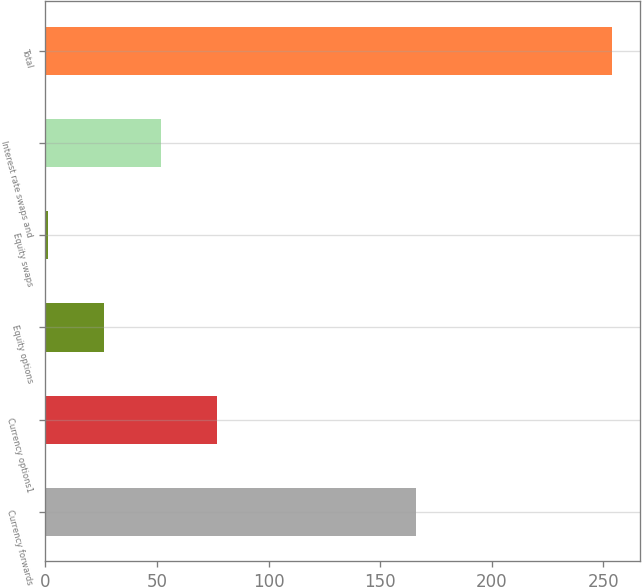Convert chart. <chart><loc_0><loc_0><loc_500><loc_500><bar_chart><fcel>Currency forwards<fcel>Currency options1<fcel>Equity options<fcel>Equity swaps<fcel>Interest rate swaps and<fcel>Total<nl><fcel>166<fcel>76.9<fcel>26.3<fcel>1<fcel>51.6<fcel>254<nl></chart> 